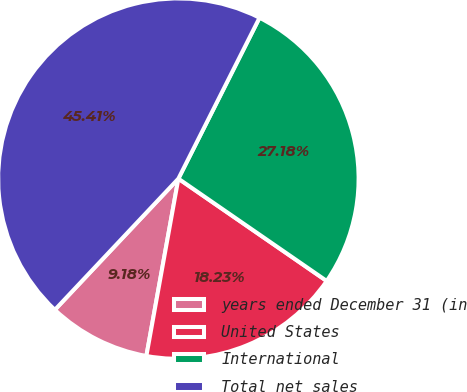<chart> <loc_0><loc_0><loc_500><loc_500><pie_chart><fcel>years ended December 31 (in<fcel>United States<fcel>International<fcel>Total net sales<nl><fcel>9.18%<fcel>18.23%<fcel>27.18%<fcel>45.41%<nl></chart> 